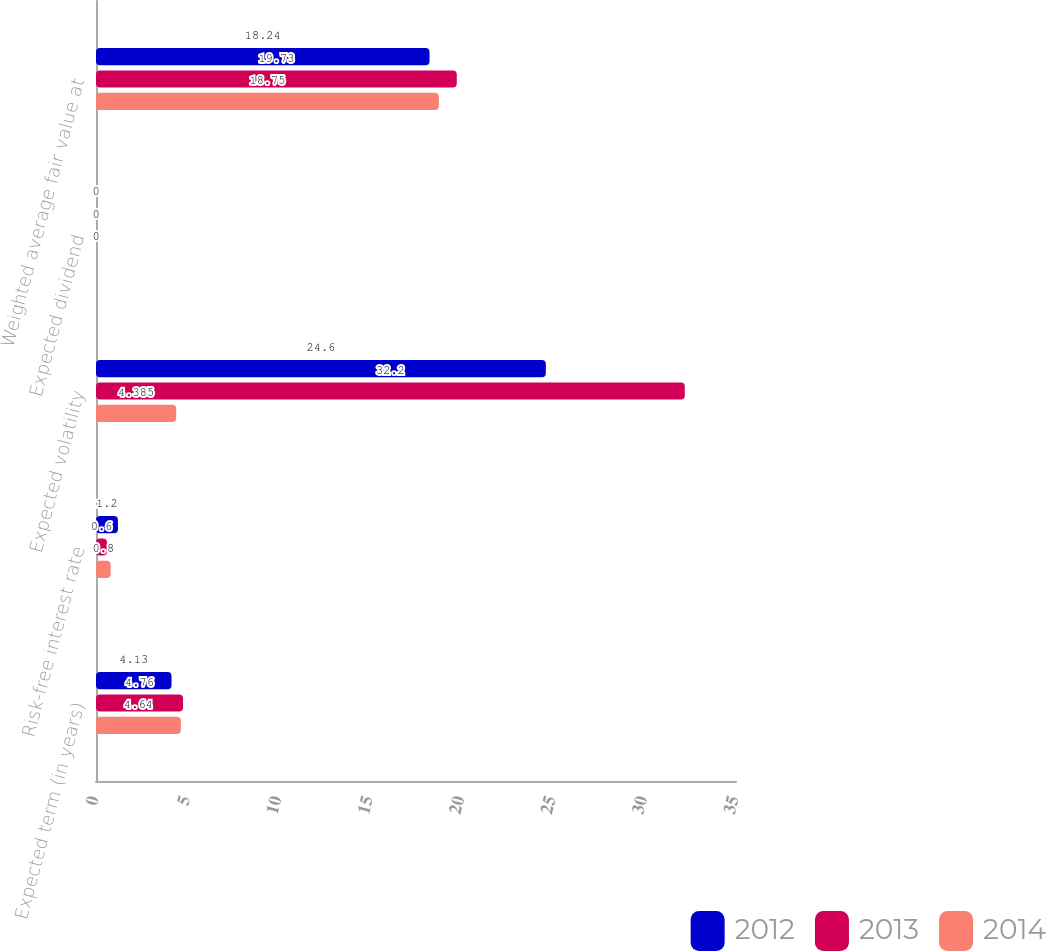<chart> <loc_0><loc_0><loc_500><loc_500><stacked_bar_chart><ecel><fcel>Expected term (in years)<fcel>Risk-free interest rate<fcel>Expected volatility<fcel>Expected dividend<fcel>Weighted average fair value at<nl><fcel>2012<fcel>4.13<fcel>1.2<fcel>24.6<fcel>0<fcel>18.24<nl><fcel>2013<fcel>4.76<fcel>0.6<fcel>32.2<fcel>0<fcel>19.73<nl><fcel>2014<fcel>4.64<fcel>0.8<fcel>4.385<fcel>0<fcel>18.75<nl></chart> 